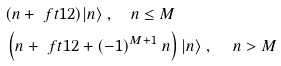Convert formula to latex. <formula><loc_0><loc_0><loc_500><loc_500>& ( n + \ f t 1 2 ) | n \rangle \ , \quad n \leq M \\ & \left ( n + \ f t 1 2 + ( - 1 ) ^ { M + 1 } \ n \right ) | n \rangle \ , \quad \, n > M</formula> 